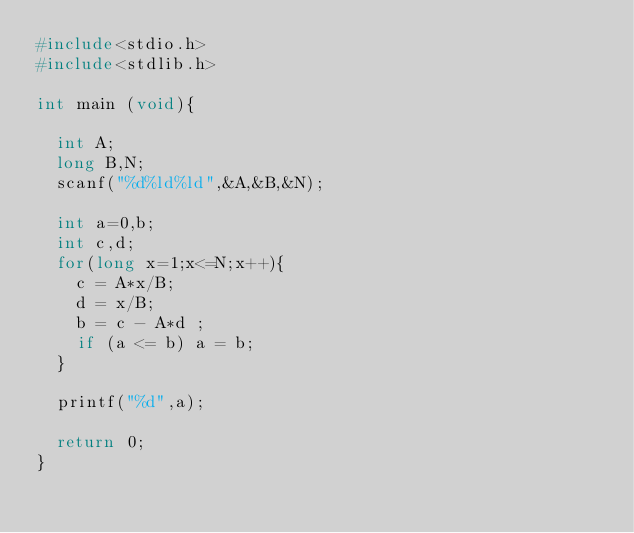<code> <loc_0><loc_0><loc_500><loc_500><_C_>#include<stdio.h>
#include<stdlib.h>

int main (void){
  
  int A;
  long B,N;
  scanf("%d%ld%ld",&A,&B,&N);
  
  int a=0,b;
  int c,d;
  for(long x=1;x<=N;x++){
    c = A*x/B;
    d = x/B;
    b = c - A*d ;
    if (a <= b) a = b;
  }
  
  printf("%d",a);
  
  return 0;
}</code> 